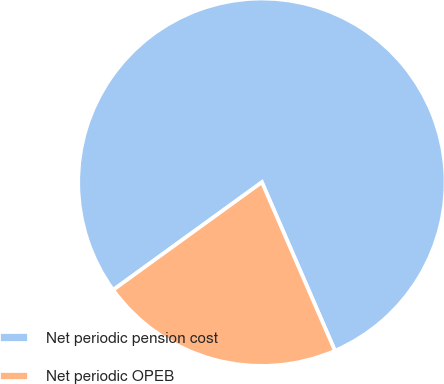<chart> <loc_0><loc_0><loc_500><loc_500><pie_chart><fcel>Net periodic pension cost<fcel>Net periodic OPEB<nl><fcel>78.46%<fcel>21.54%<nl></chart> 